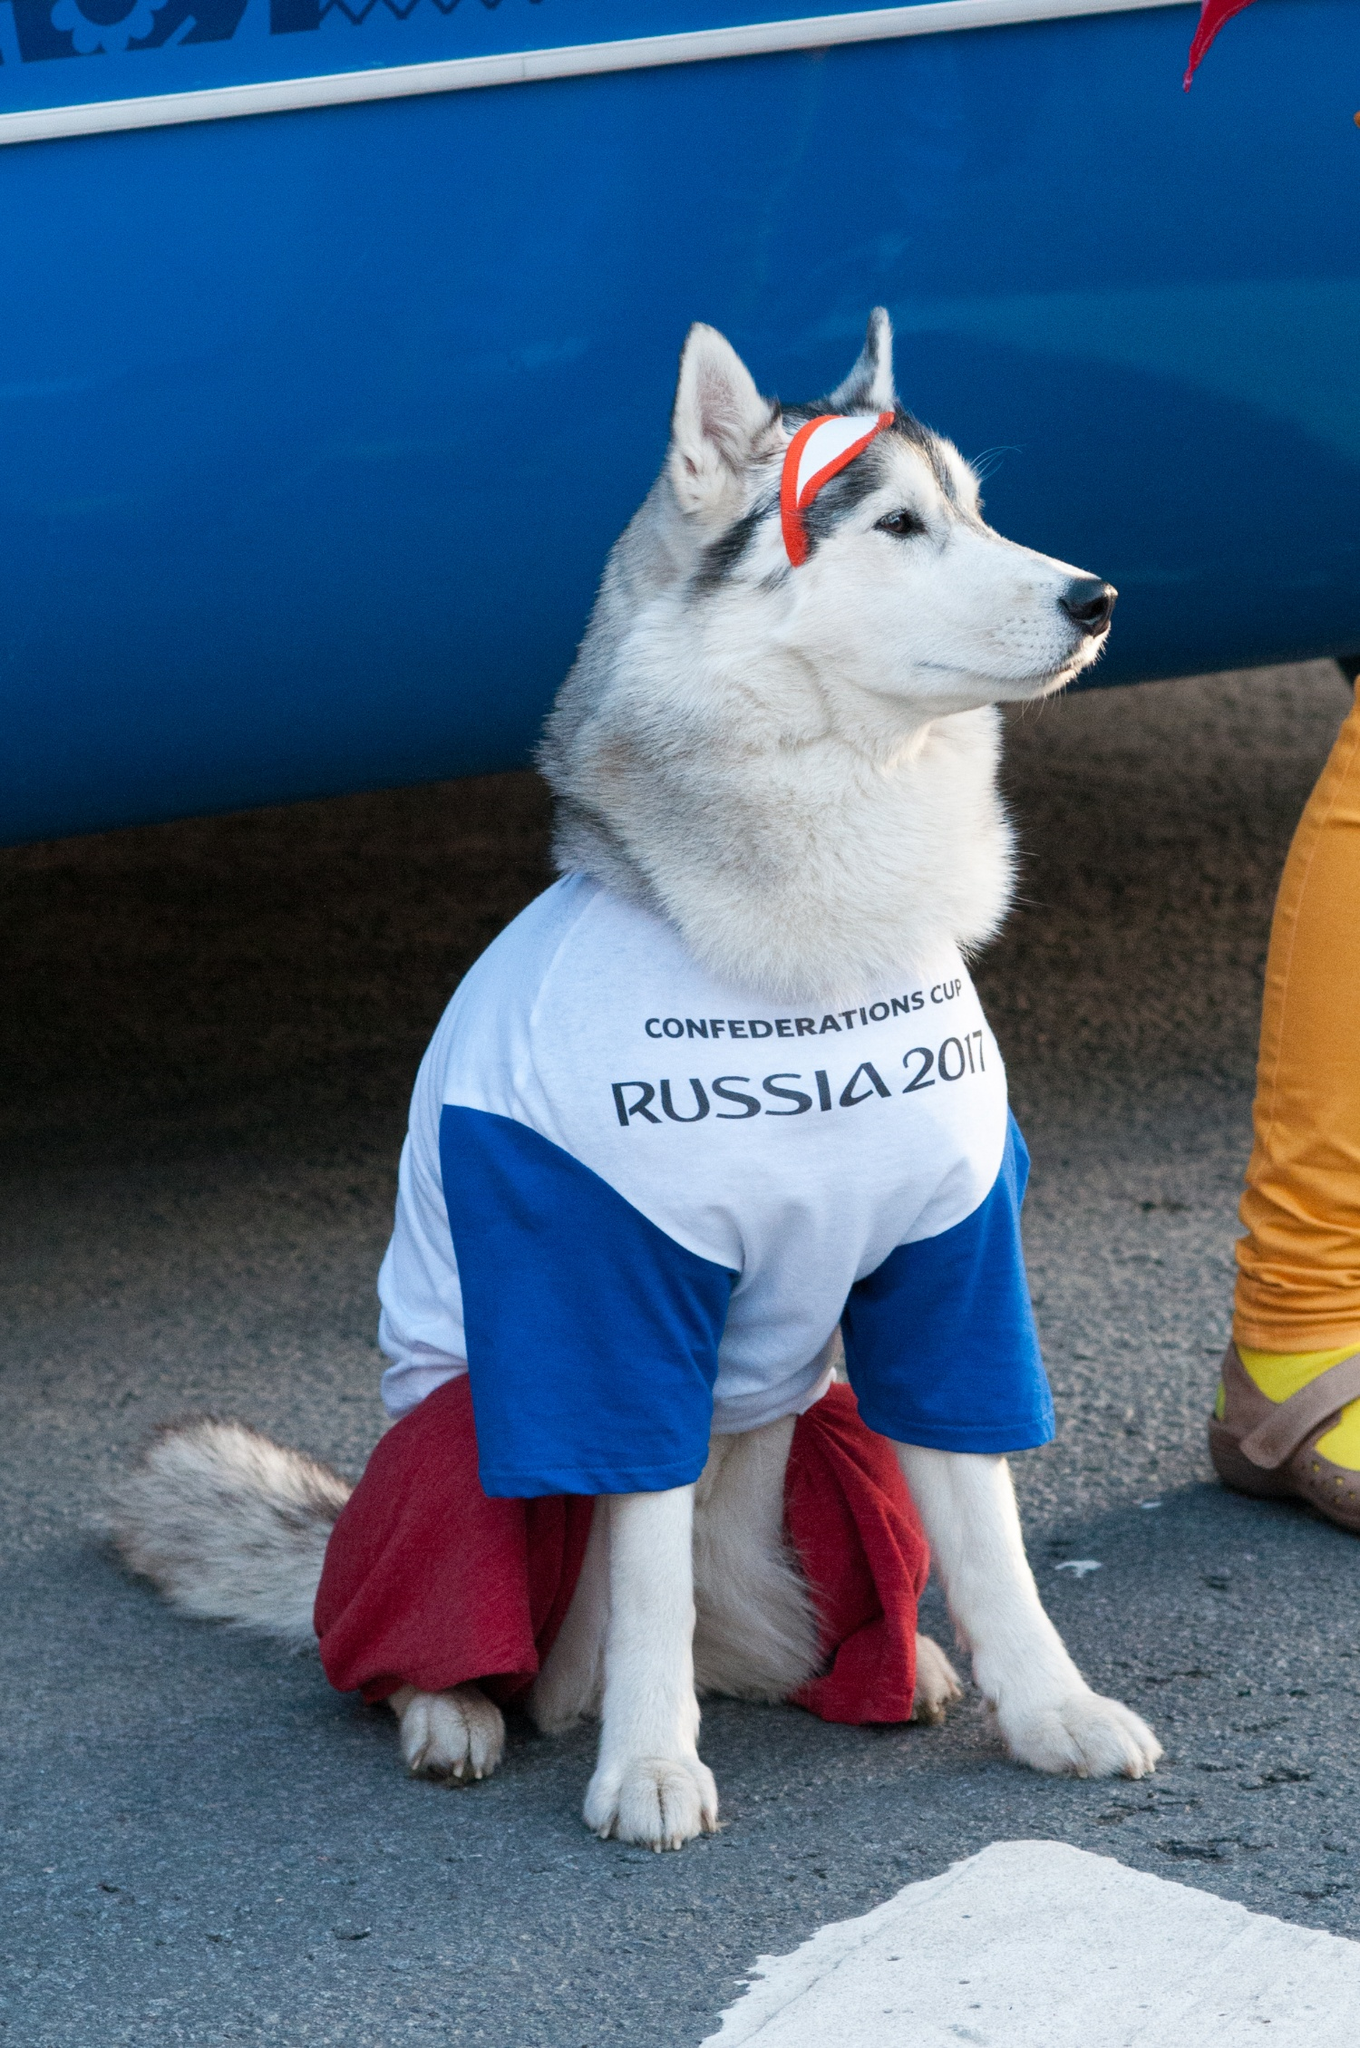Can you provide a brief description of the environment in which this dog is situated? The dog is sitting on what appears to be a paved surface, possibly a street or sidewalk, in front of a bright blue banner. The scene indicates a lively event setting. What might be the significance of the dog's attire? The dog's attire, including the t-shirt with 'CONFEDERATIONS CUP RUSSIA 2017,' suggests that the dog is dressed for a specific sporting event or celebration associated with the Confederations Cup held in Russia in 2017. The red pants and headband also indicate festive participation, highlighting the event's theme colors. Imagine if the dog could give a speech at the event. What might it say? Greetings everyone! Woof! I am here to welcome you to the Confederations Cup 2017! I hope you're as excited as I am for the thrilling matches and the celebration of sportsmanship. Let's cheer for our teams and enjoy every moment. Go teams! Given the festive attire, could this event be part of a larger celebration? Provide a detailed scenario. Definitely! This event is likely part of a grand festival celebrating the Confederations Cup 2017. The streets are lined with colorful banners, flags of various nations fluttering in the breeze, and spectators donning the colors of their favorite teams. Street vendors offer themed merchandise and foods from different countries. Various activities, such as face painting, live music performances, and street parades, fill the air with excitement. The dog, dressed in event-themed attire, interacts with visitors, posing for photos and spreading cheer. It's a lively atmosphere, uniting people from different cultures through the love of football and celebration. 